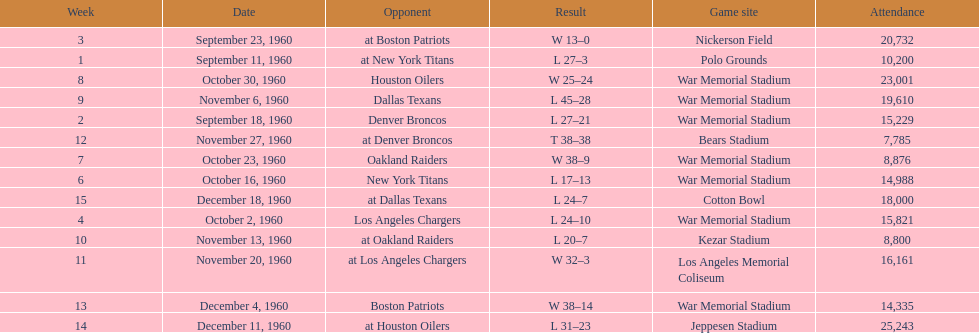How many games had an attendance of 10,000 at most? 11. 